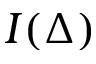<formula> <loc_0><loc_0><loc_500><loc_500>I ( \Delta )</formula> 